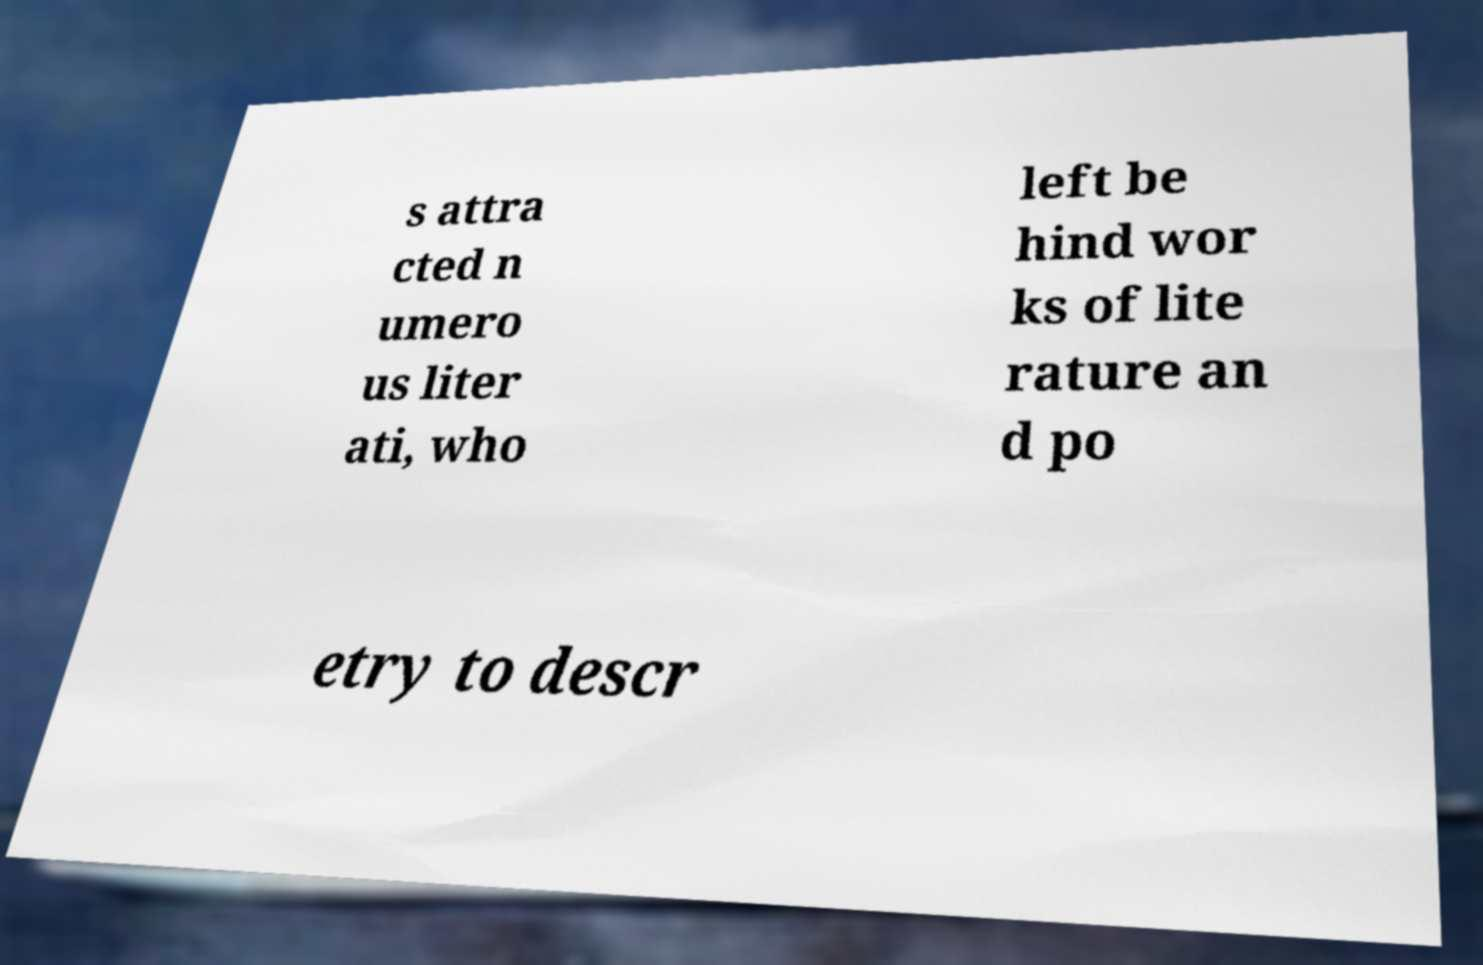Could you assist in decoding the text presented in this image and type it out clearly? s attra cted n umero us liter ati, who left be hind wor ks of lite rature an d po etry to descr 